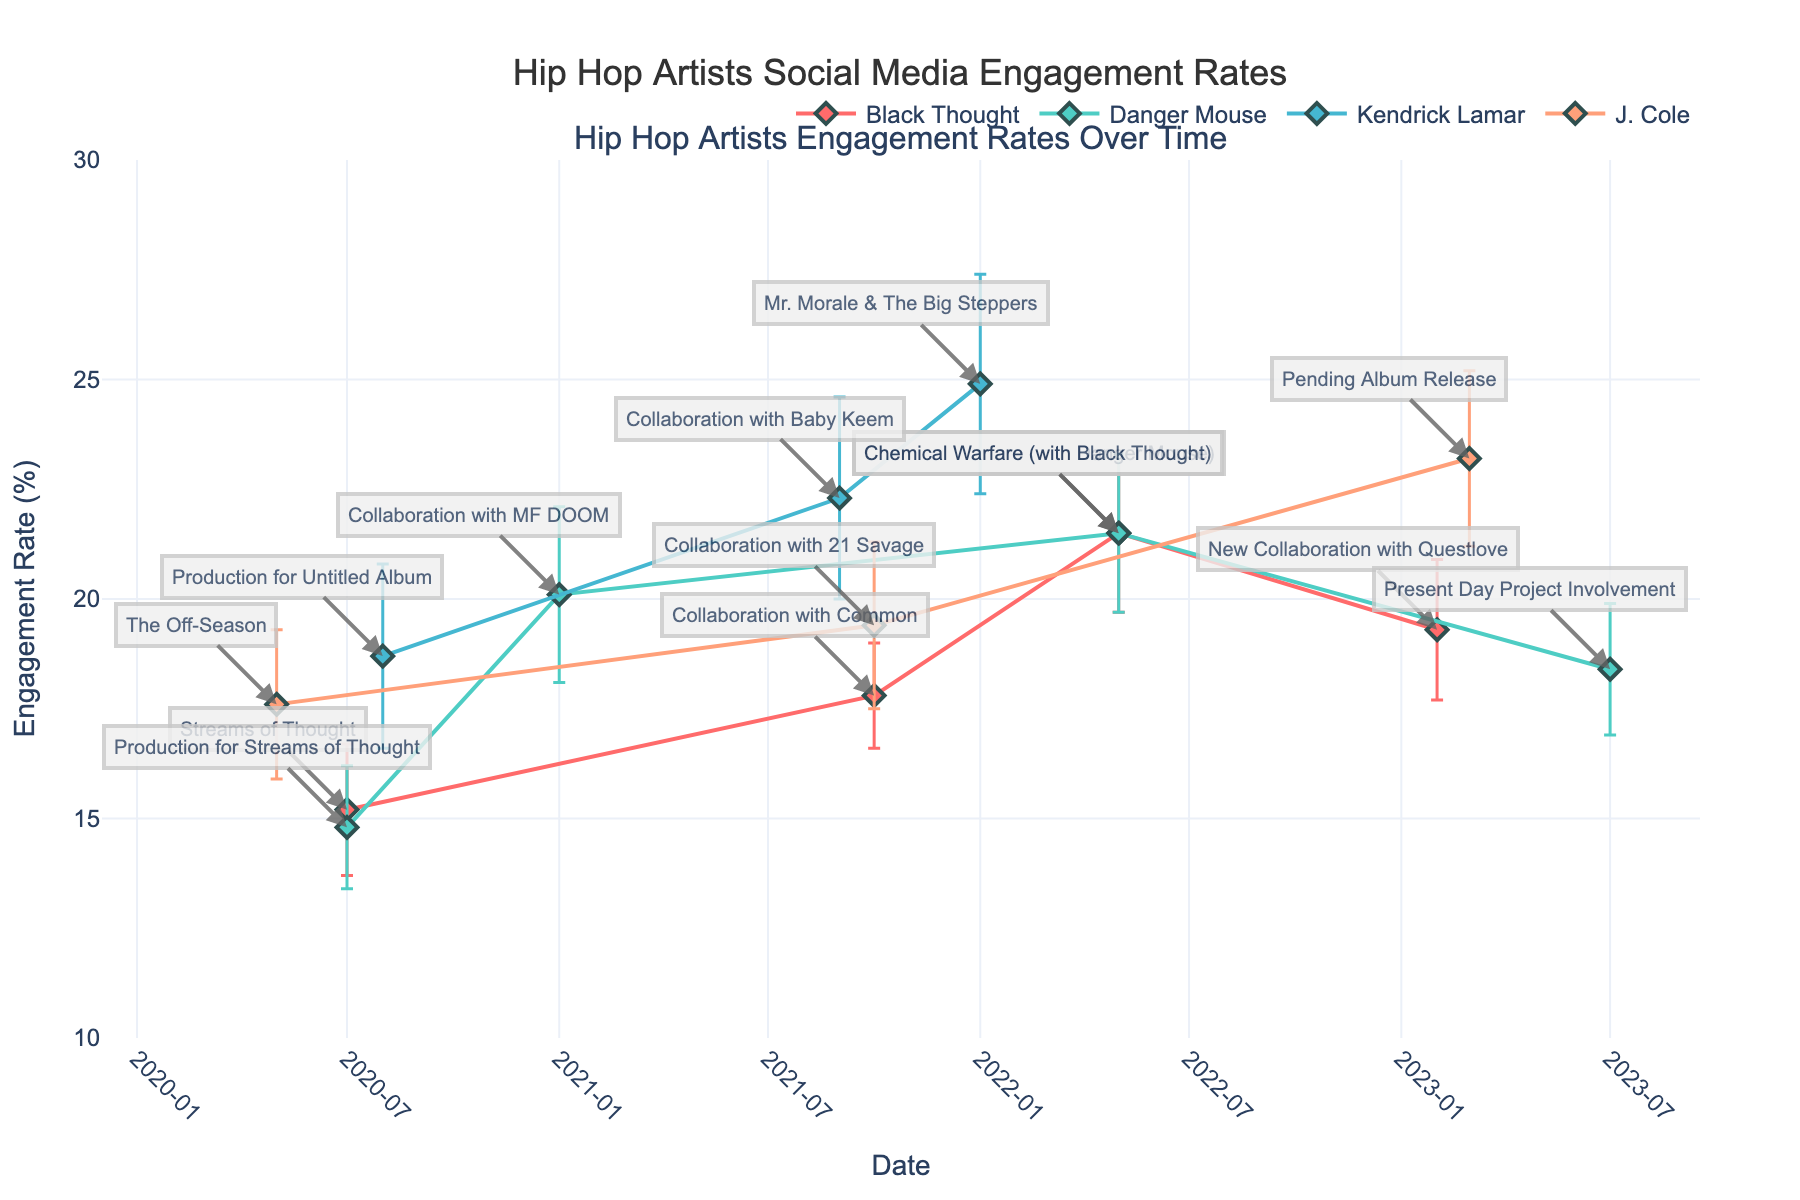What is the title of the plot? The title can typically be found at the top of the plot. In this case, it's clearly noted: "Hip Hop Artists Social Media Engagement Rates".
Answer: Hip Hop Artists Social Media Engagement Rates Which artist has the highest engagement rate in the data? To find the highest engagement rate, look at the y-axis values across all data points. Kendrick Lamar with "Mr. Morale & The Big Steppers" at 24.9% is the highest.
Answer: Kendrick Lamar On which date did Black Thought collaborate with Danger Mouse? The date of the collaboration can be found by looking at the x-axis value corresponding to the point labeled "Chemical Warfare (with Danger Mouse)" for Black Thought.
Answer: 2022-05 Compare the engagement rates of Black Thought and Danger Mouse in May 2022. Who has a higher value? Both of these artists have a data point for May 2022. Checking the y-axis value, both have an engagement rate of 21.5%.
Answer: Both have the same engagement rate What is the range of engagement rates for Danger Mouse? The range is found by looking at the y-axis values for Danger Mouse’s data points. The minimum is 14.8% and the maximum is 21.5%.
Answer: 14.8% to 21.5% What was the engagement rate for J. Cole at the beginning and end of the data? Check J. Cole's y-axis values in May 2020 (The Off-Season) and March 2023 (Pending Album Release). They are 17.6% and 23.2%, respectively.
Answer: 17.6% and 23.2% Calculate the average engagement rate for Black Thought across all data points. To calculate the average, sum the engagement rates of 15.2, 17.8, 21.5, and 19.3, then divide by 4. The total is 73.8, so the average is 73.8 / 4 = 18.45.
Answer: 18.45 Which artist saw the largest increase in engagement rate between any two points in time? To find the largest increase, calculate the differences between consecutive points for each artist. Kendrick Lamar saw an increase from 18.7% to 24.9% between August 2020 and January 2022, a rise of 6.2%.
Answer: Kendrick Lamar How do the error bars for Kendrick Lamar's 2022-01 data point compare to those for J. Cole's 2023-03 data point? Error bars visualize uncertainty. Kendrick Lamar's error bar in January 2022 spans from (24.9 - 2.5) to (24.9 + 2.5), 22.4 to 27.4. J. Cole's error bar in March 2023 spans from (23.2 - 2.0) to (23.2 + 2.0), 21.2 to 25.2.
Answer: Kendrick Lamar's error bars are wider 